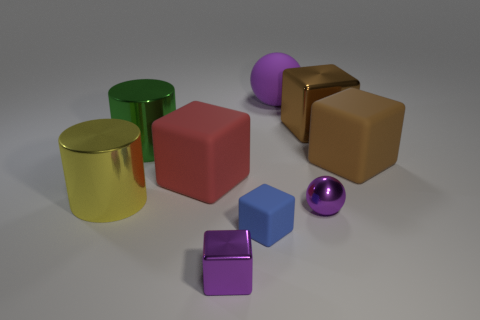Subtract all small purple blocks. How many blocks are left? 4 Subtract all purple blocks. How many blocks are left? 4 Subtract all yellow cubes. Subtract all cyan cylinders. How many cubes are left? 5 Add 1 small purple shiny blocks. How many objects exist? 10 Subtract all cubes. How many objects are left? 4 Subtract all metallic spheres. Subtract all large shiny cylinders. How many objects are left? 6 Add 6 large metal cubes. How many large metal cubes are left? 7 Add 1 purple blocks. How many purple blocks exist? 2 Subtract 0 green balls. How many objects are left? 9 